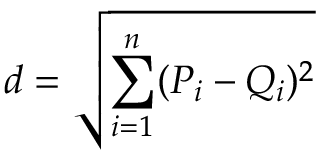<formula> <loc_0><loc_0><loc_500><loc_500>d = \sqrt { \sum _ { i = 1 } ^ { n } ( P _ { i } - Q _ { i } ) ^ { 2 } }</formula> 